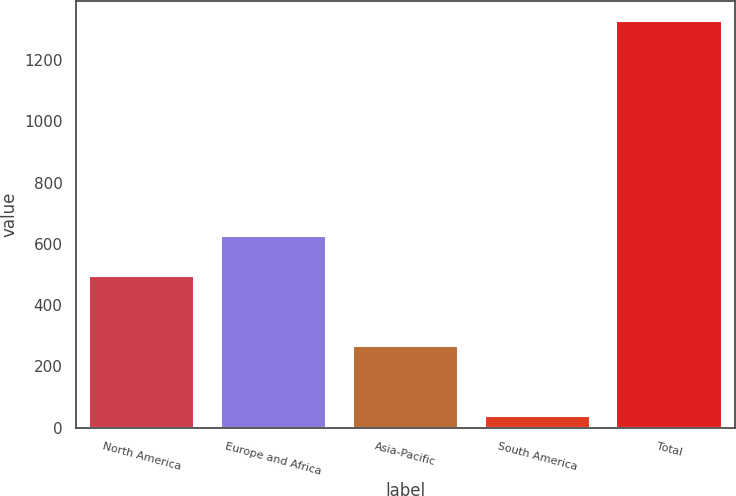Convert chart. <chart><loc_0><loc_0><loc_500><loc_500><bar_chart><fcel>North America<fcel>Europe and Africa<fcel>Asia-Pacific<fcel>South America<fcel>Total<nl><fcel>496<fcel>624.8<fcel>266<fcel>38<fcel>1326<nl></chart> 